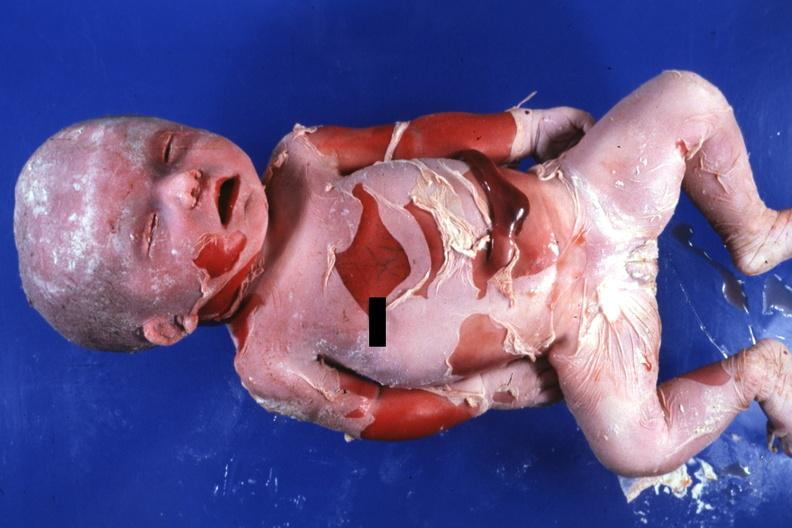what does this image show?
Answer the question using a single word or phrase. Natural color advanced typical 